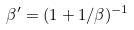Convert formula to latex. <formula><loc_0><loc_0><loc_500><loc_500>\beta ^ { \prime } = ( 1 + 1 / \beta ) ^ { - 1 }</formula> 